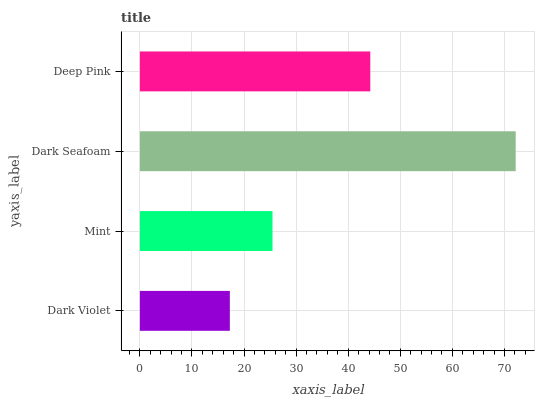Is Dark Violet the minimum?
Answer yes or no. Yes. Is Dark Seafoam the maximum?
Answer yes or no. Yes. Is Mint the minimum?
Answer yes or no. No. Is Mint the maximum?
Answer yes or no. No. Is Mint greater than Dark Violet?
Answer yes or no. Yes. Is Dark Violet less than Mint?
Answer yes or no. Yes. Is Dark Violet greater than Mint?
Answer yes or no. No. Is Mint less than Dark Violet?
Answer yes or no. No. Is Deep Pink the high median?
Answer yes or no. Yes. Is Mint the low median?
Answer yes or no. Yes. Is Dark Violet the high median?
Answer yes or no. No. Is Dark Seafoam the low median?
Answer yes or no. No. 